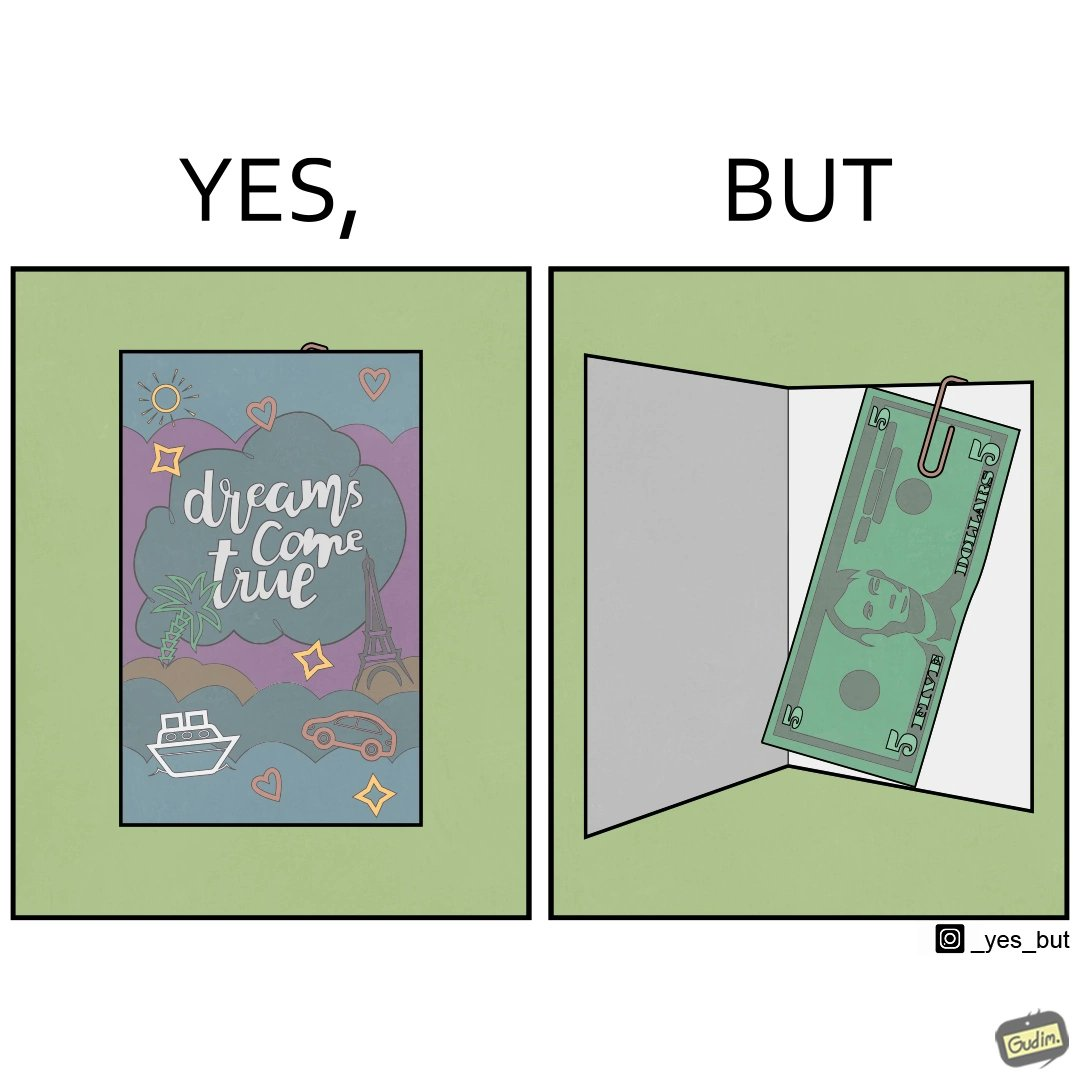What is shown in this image? The overall image is funny because while the front of the card gives hope that the person receiving this card will have one of their dreams come true but opening the card reveals only 5 dollars which is nowhere enough to fulfil any kind of dream. 